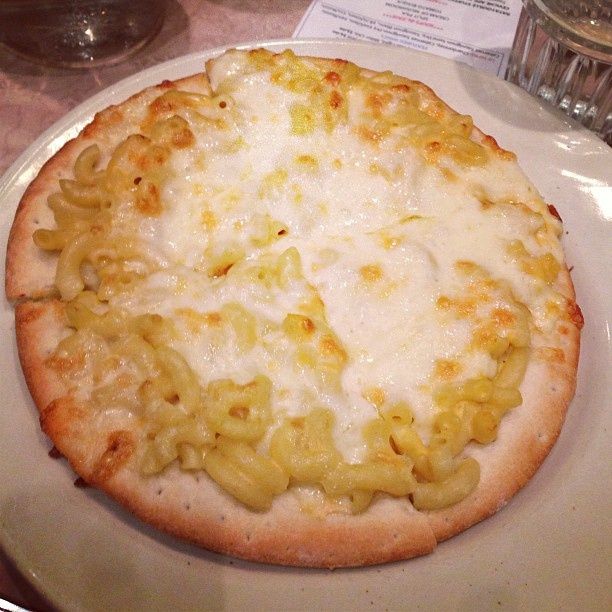Describe the objects in this image and their specific colors. I can see dining table in tan and gray tones, pizza in maroon, tan, and red tones, and cup in maroon and brown tones in this image. 